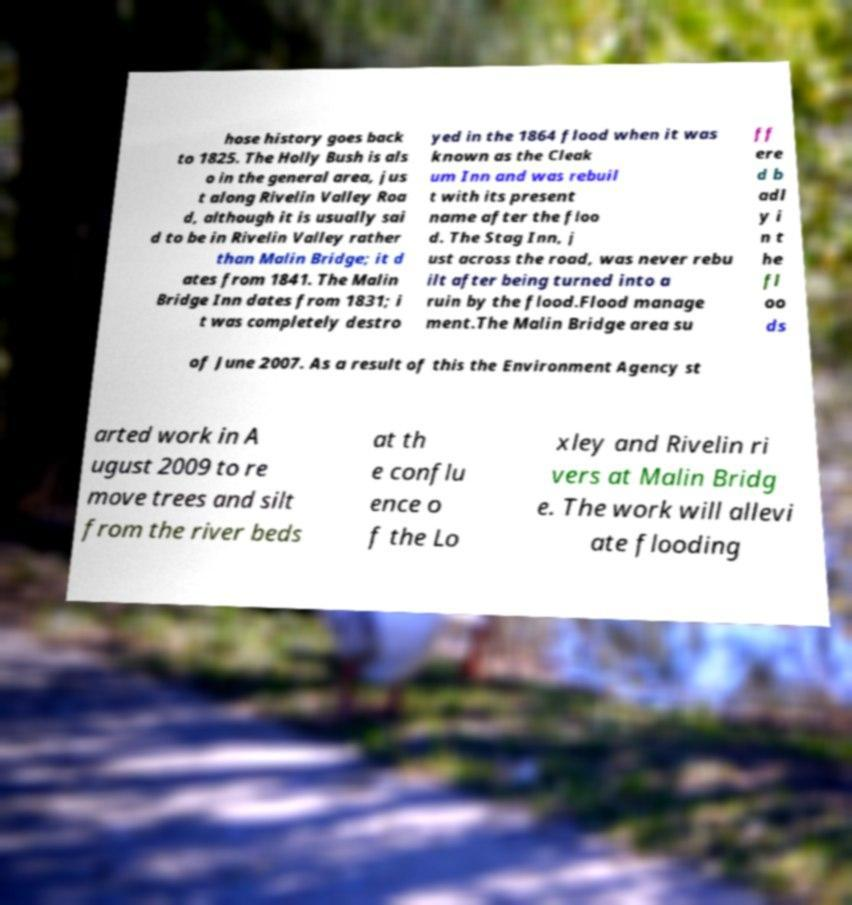For documentation purposes, I need the text within this image transcribed. Could you provide that? hose history goes back to 1825. The Holly Bush is als o in the general area, jus t along Rivelin Valley Roa d, although it is usually sai d to be in Rivelin Valley rather than Malin Bridge; it d ates from 1841. The Malin Bridge Inn dates from 1831; i t was completely destro yed in the 1864 flood when it was known as the Cleak um Inn and was rebuil t with its present name after the floo d. The Stag Inn, j ust across the road, was never rebu ilt after being turned into a ruin by the flood.Flood manage ment.The Malin Bridge area su ff ere d b adl y i n t he fl oo ds of June 2007. As a result of this the Environment Agency st arted work in A ugust 2009 to re move trees and silt from the river beds at th e conflu ence o f the Lo xley and Rivelin ri vers at Malin Bridg e. The work will allevi ate flooding 